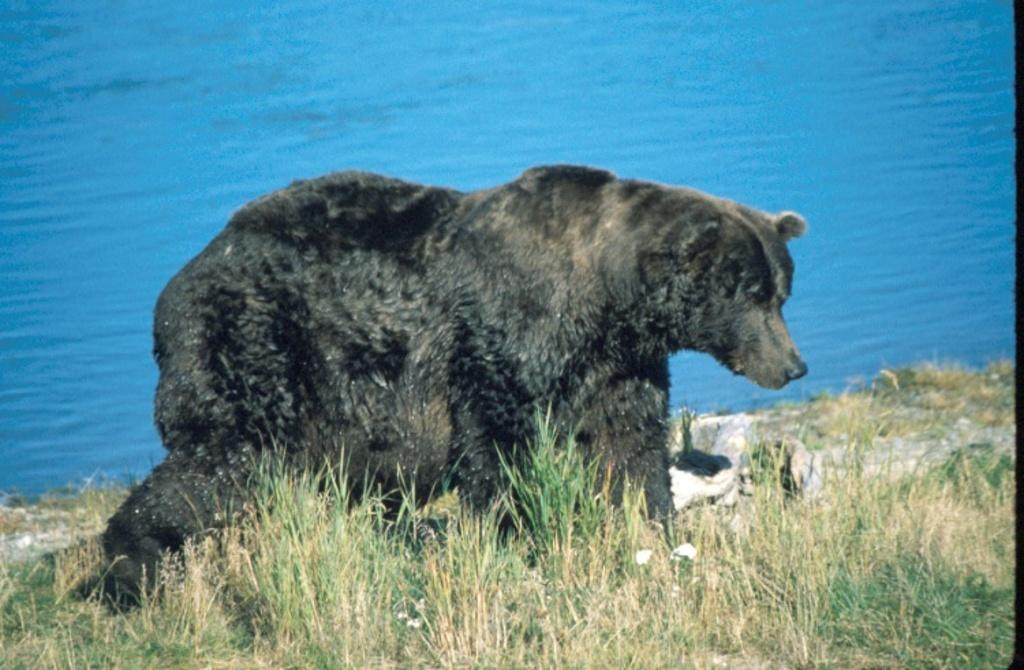What animal is on the ground in the image? There is a bear on the ground in the image. What type of terrain is visible in the image? There is grass visible in the image. What else can be seen in the image? There is water visible in the image. What type of teaching method is the bear using in the image? There is no indication of teaching or any educational activity in the image. The bear is simply on the ground, and the focus is on the grass and water visible in the image. 